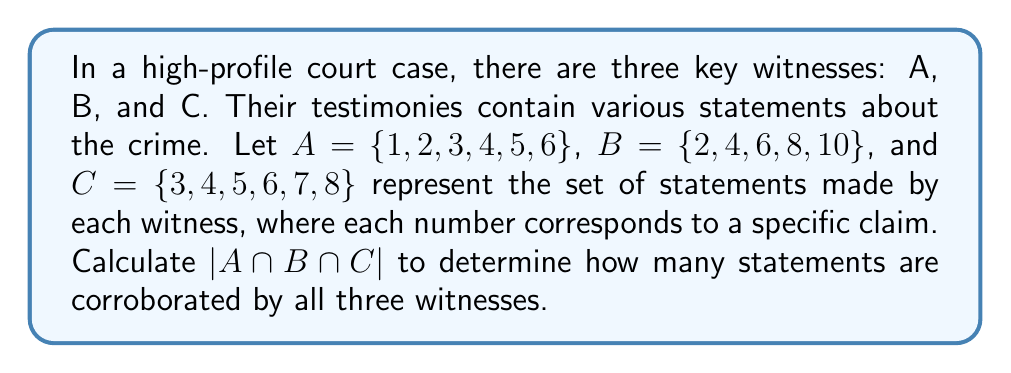Help me with this question. To solve this problem, we need to find the intersection of all three sets and then determine its cardinality. Let's approach this step-by-step:

1) First, let's identify the elements that are common to all three sets:
   $A = \{1, 2, 3, 4, 5, 6\}$
   $B = \{2, 4, 6, 8, 10\}$
   $C = \{3, 4, 5, 6, 7, 8\}$

2) We can see that the numbers 4 and 6 appear in all three sets.

3) Therefore, the intersection of A, B, and C is:
   $A \cap B \cap C = \{4, 6\}$

4) The cardinality of a set is denoted by vertical bars around the set. In this case:
   $|A \cap B \cap C| = |\{4, 6\}| = 2$

This means that there are 2 statements that are corroborated by all three witnesses.
Answer: $|A \cap B \cap C| = 2$ 